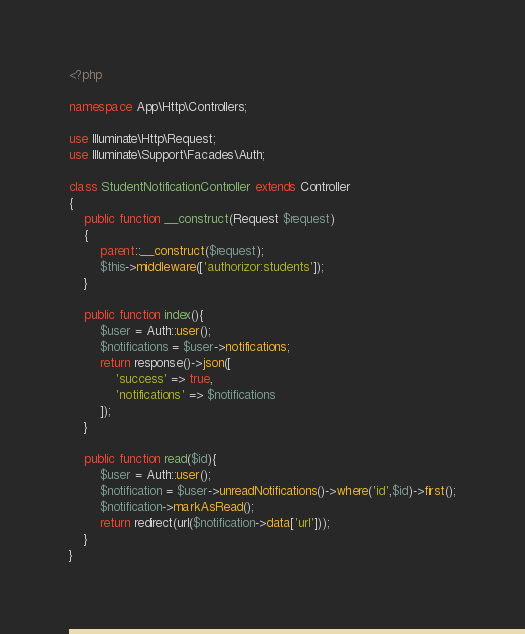Convert code to text. <code><loc_0><loc_0><loc_500><loc_500><_PHP_><?php

namespace App\Http\Controllers;

use Illuminate\Http\Request;
use Illuminate\Support\Facades\Auth;

class StudentNotificationController extends Controller
{
    public function __construct(Request $request)
    {
        parent::__construct($request);
        $this->middleware(['authorizor:students']);
    }

    public function index(){
        $user = Auth::user();
        $notifications = $user->notifications;
        return response()->json([
            'success' => true,
            'notifications' => $notifications
        ]);
    }

    public function read($id){
        $user = Auth::user();
        $notification = $user->unreadNotifications()->where('id',$id)->first();
        $notification->markAsRead();
        return redirect(url($notification->data['url']));
    }
}
</code> 